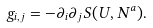Convert formula to latex. <formula><loc_0><loc_0><loc_500><loc_500>g _ { i , j } = - \partial _ { i } \partial _ { j } S ( U , N ^ { a } ) .</formula> 